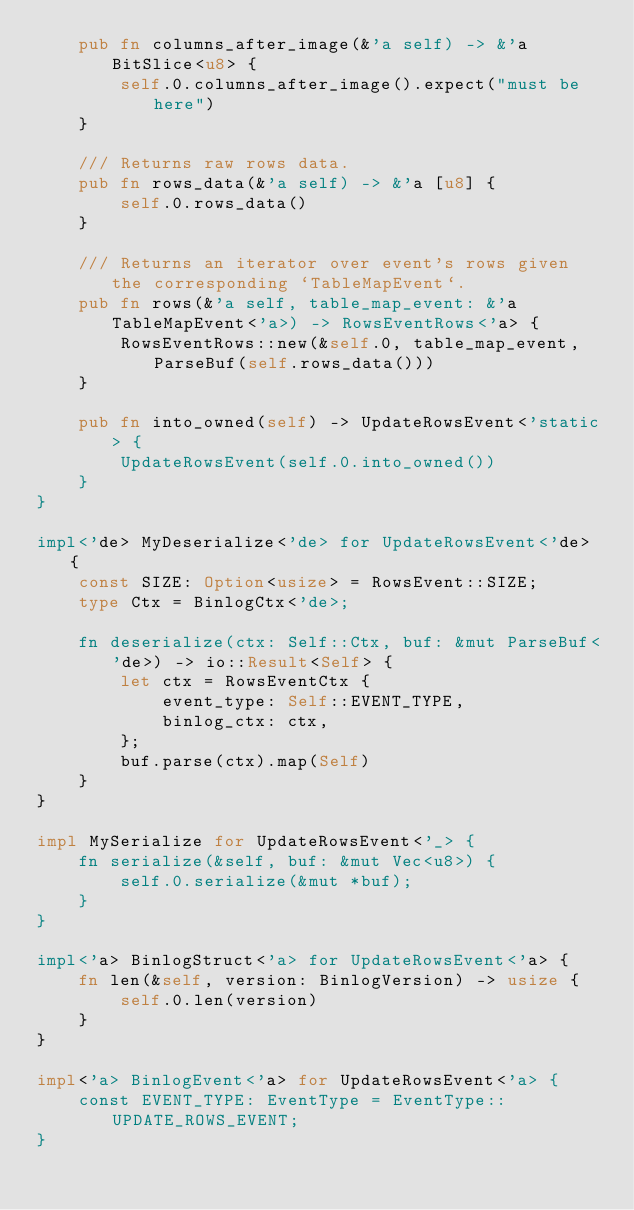<code> <loc_0><loc_0><loc_500><loc_500><_Rust_>    pub fn columns_after_image(&'a self) -> &'a BitSlice<u8> {
        self.0.columns_after_image().expect("must be here")
    }

    /// Returns raw rows data.
    pub fn rows_data(&'a self) -> &'a [u8] {
        self.0.rows_data()
    }

    /// Returns an iterator over event's rows given the corresponding `TableMapEvent`.
    pub fn rows(&'a self, table_map_event: &'a TableMapEvent<'a>) -> RowsEventRows<'a> {
        RowsEventRows::new(&self.0, table_map_event, ParseBuf(self.rows_data()))
    }

    pub fn into_owned(self) -> UpdateRowsEvent<'static> {
        UpdateRowsEvent(self.0.into_owned())
    }
}

impl<'de> MyDeserialize<'de> for UpdateRowsEvent<'de> {
    const SIZE: Option<usize> = RowsEvent::SIZE;
    type Ctx = BinlogCtx<'de>;

    fn deserialize(ctx: Self::Ctx, buf: &mut ParseBuf<'de>) -> io::Result<Self> {
        let ctx = RowsEventCtx {
            event_type: Self::EVENT_TYPE,
            binlog_ctx: ctx,
        };
        buf.parse(ctx).map(Self)
    }
}

impl MySerialize for UpdateRowsEvent<'_> {
    fn serialize(&self, buf: &mut Vec<u8>) {
        self.0.serialize(&mut *buf);
    }
}

impl<'a> BinlogStruct<'a> for UpdateRowsEvent<'a> {
    fn len(&self, version: BinlogVersion) -> usize {
        self.0.len(version)
    }
}

impl<'a> BinlogEvent<'a> for UpdateRowsEvent<'a> {
    const EVENT_TYPE: EventType = EventType::UPDATE_ROWS_EVENT;
}
</code> 